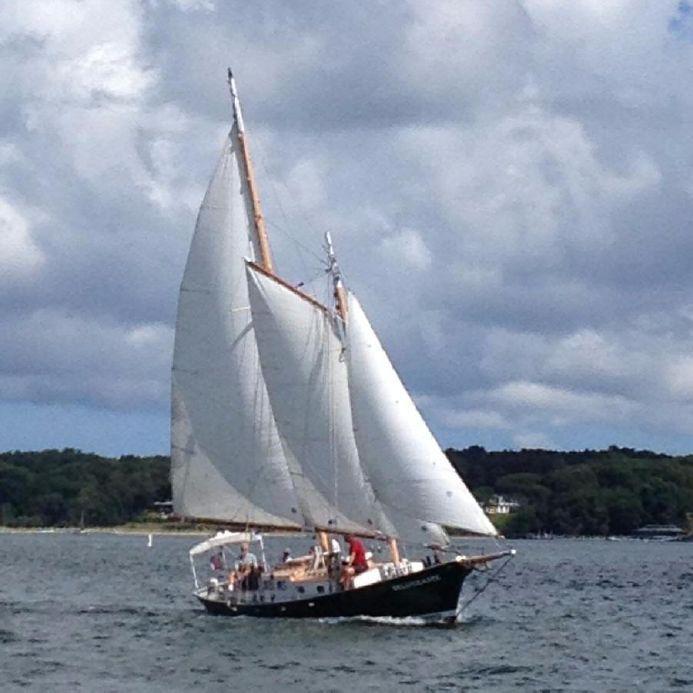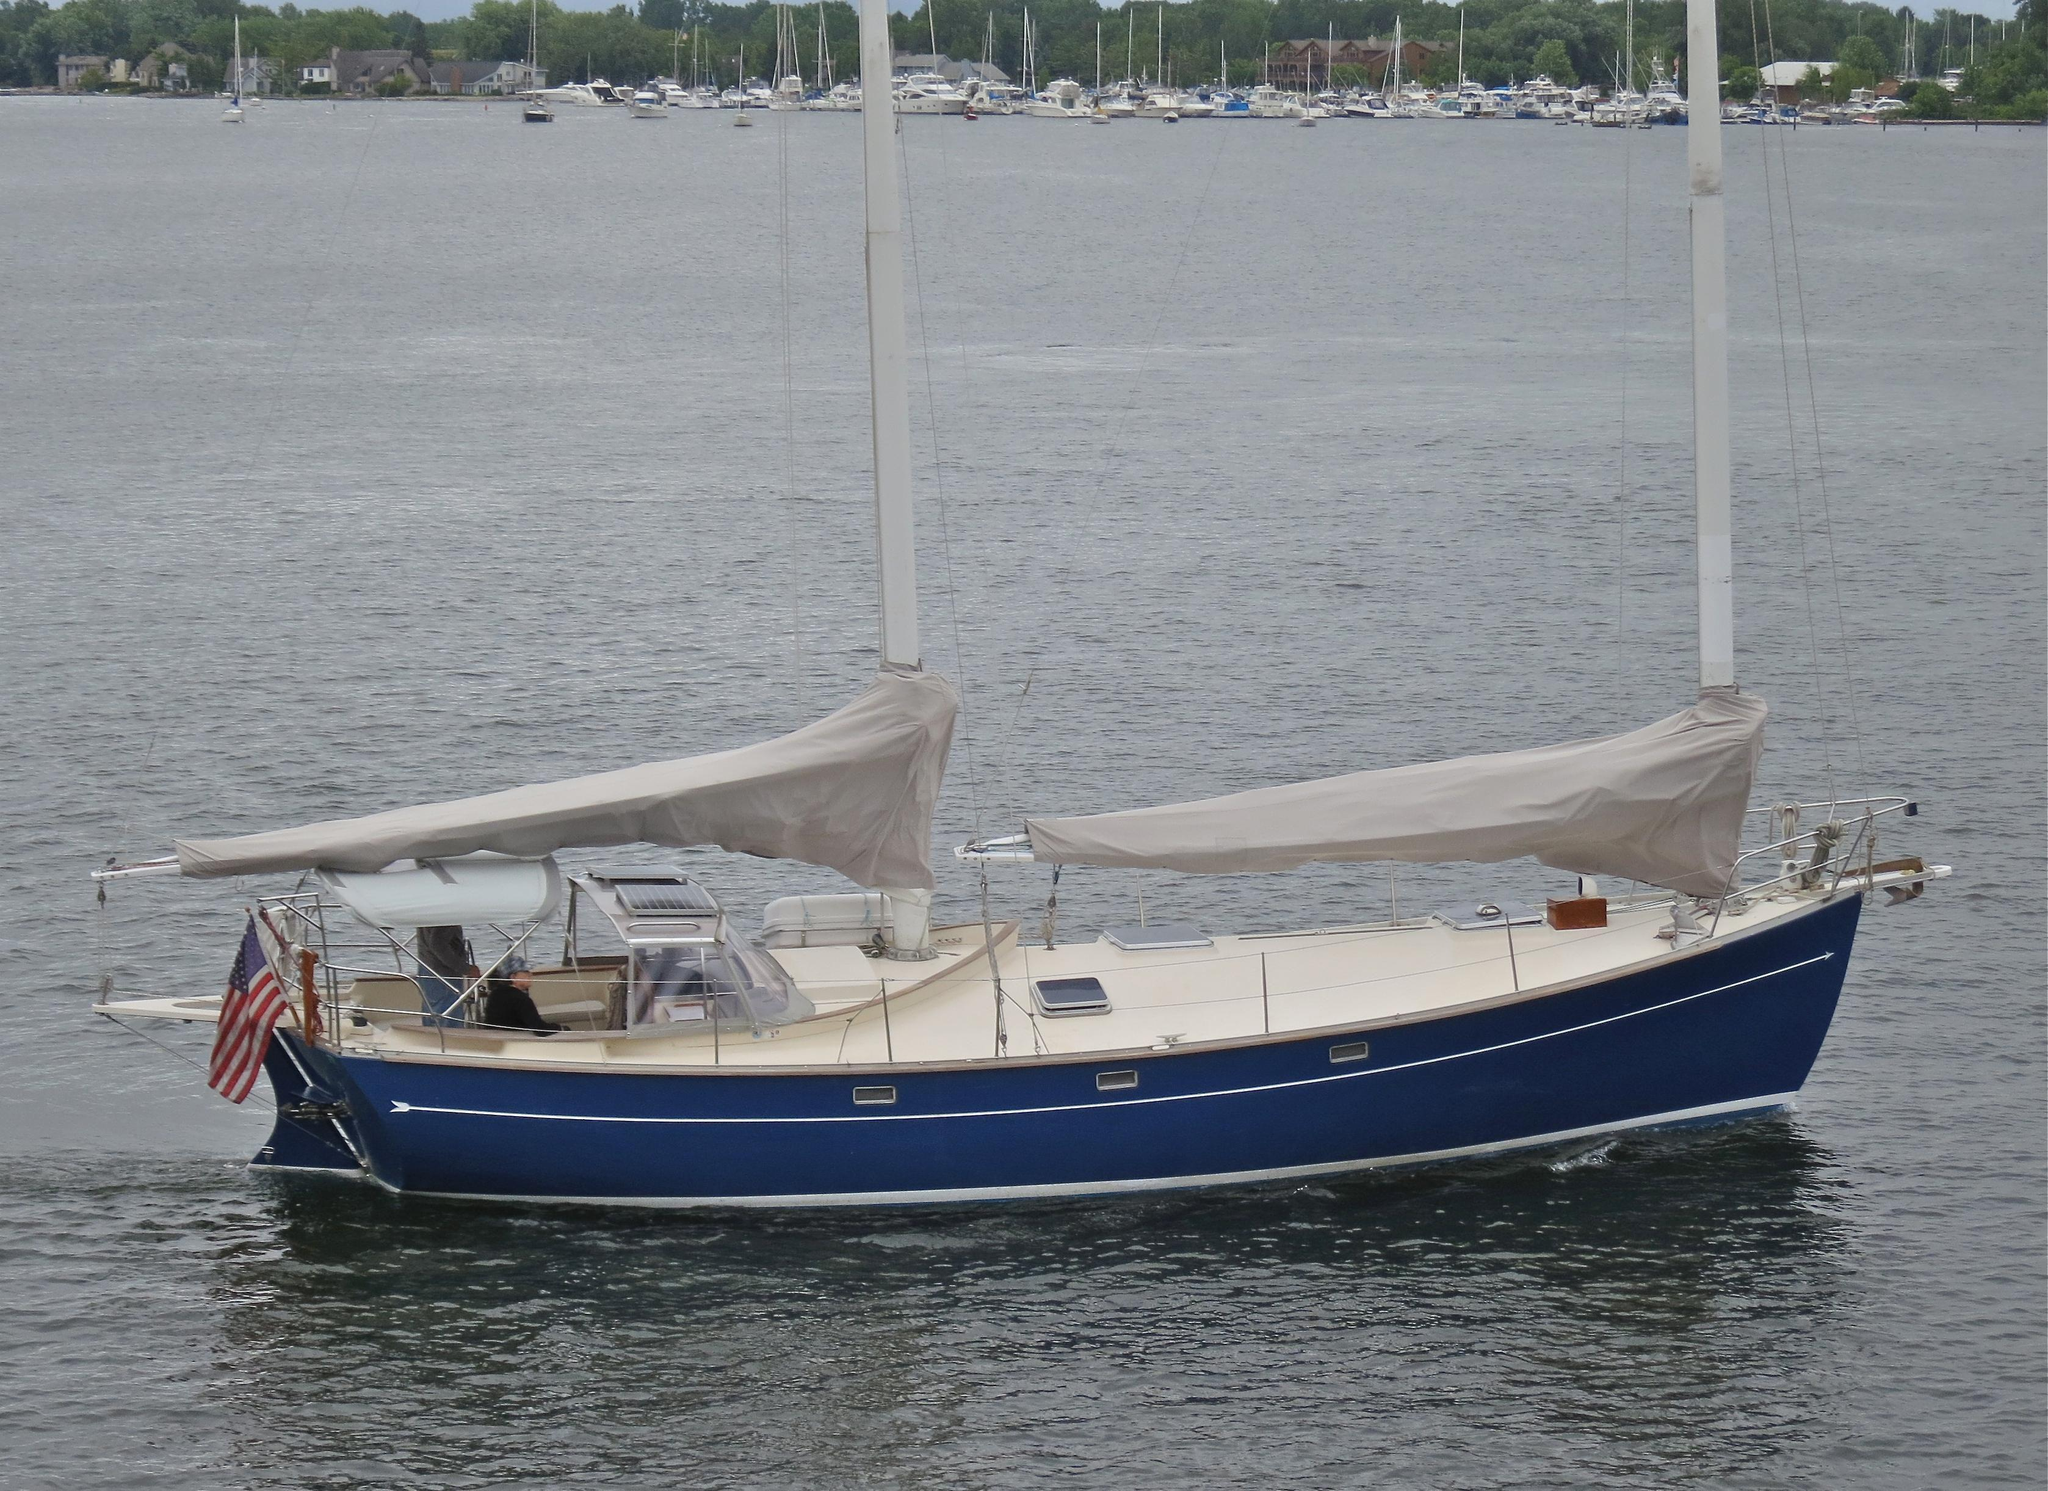The first image is the image on the left, the second image is the image on the right. Considering the images on both sides, is "The left and right image contains a total of three boats." valid? Answer yes or no. No. The first image is the image on the left, the second image is the image on the right. For the images displayed, is the sentence "The boat in the left image has a blue hull, and the boats in the left and right images have their sails in the same position [furled or unfurled]." factually correct? Answer yes or no. No. 